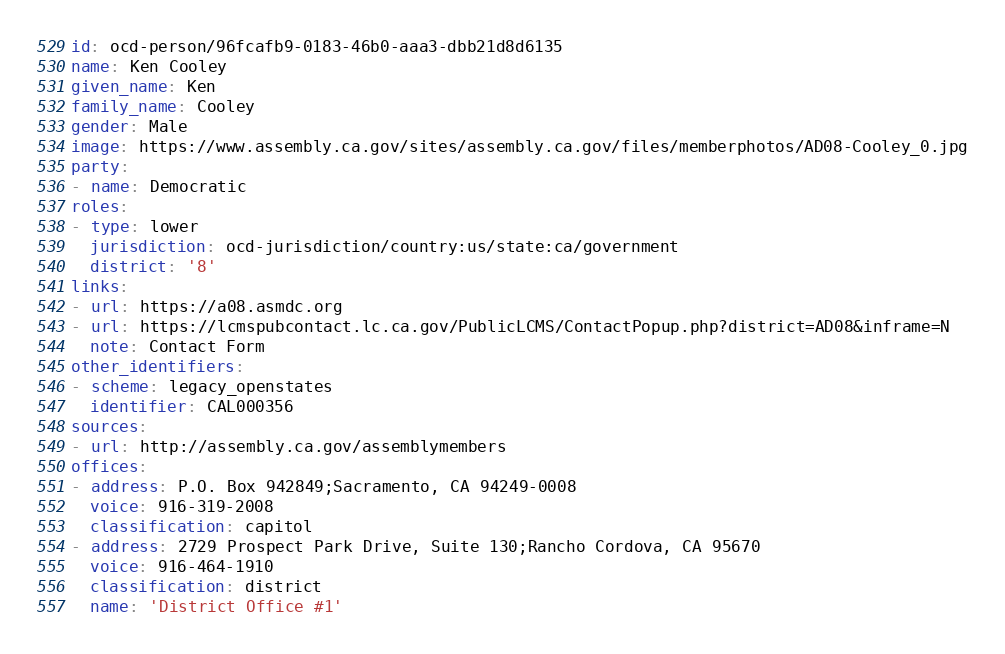<code> <loc_0><loc_0><loc_500><loc_500><_YAML_>id: ocd-person/96fcafb9-0183-46b0-aaa3-dbb21d8d6135
name: Ken Cooley
given_name: Ken
family_name: Cooley
gender: Male
image: https://www.assembly.ca.gov/sites/assembly.ca.gov/files/memberphotos/AD08-Cooley_0.jpg
party:
- name: Democratic
roles:
- type: lower
  jurisdiction: ocd-jurisdiction/country:us/state:ca/government
  district: '8'
links:
- url: https://a08.asmdc.org
- url: https://lcmspubcontact.lc.ca.gov/PublicLCMS/ContactPopup.php?district=AD08&inframe=N
  note: Contact Form
other_identifiers:
- scheme: legacy_openstates
  identifier: CAL000356
sources:
- url: http://assembly.ca.gov/assemblymembers
offices:
- address: P.O. Box 942849;Sacramento, CA 94249-0008
  voice: 916-319-2008
  classification: capitol
- address: 2729 Prospect Park Drive, Suite 130;Rancho Cordova, CA 95670
  voice: 916-464-1910
  classification: district
  name: 'District Office #1'
</code> 